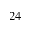Convert formula to latex. <formula><loc_0><loc_0><loc_500><loc_500>_ { 2 4 }</formula> 